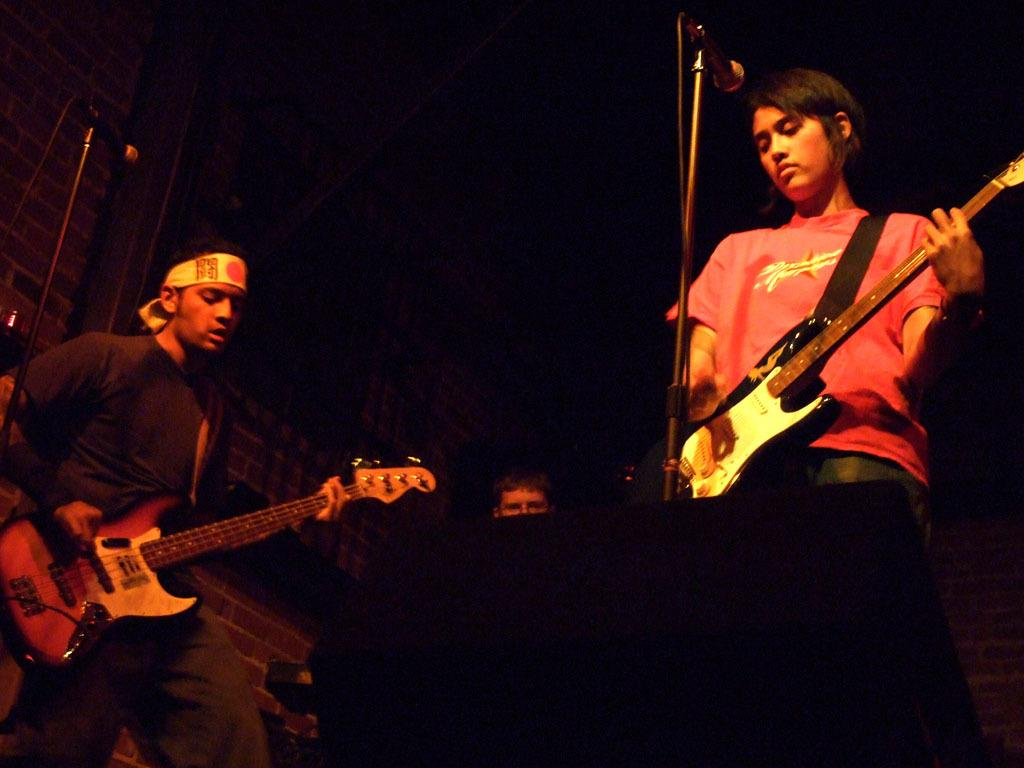Who or what is present in the image? There are people in the image. What are the people doing in the image? The people are standing and playing musical instruments. What objects are in front of the people? There are microphones in front of the people. How would you describe the background of the image? The background of the image is dark. Can you see any snow or railway in the image? No, there is no snow or railway present in the image. Is there a bike visible in the image? No, there is no bike visible in the image. 